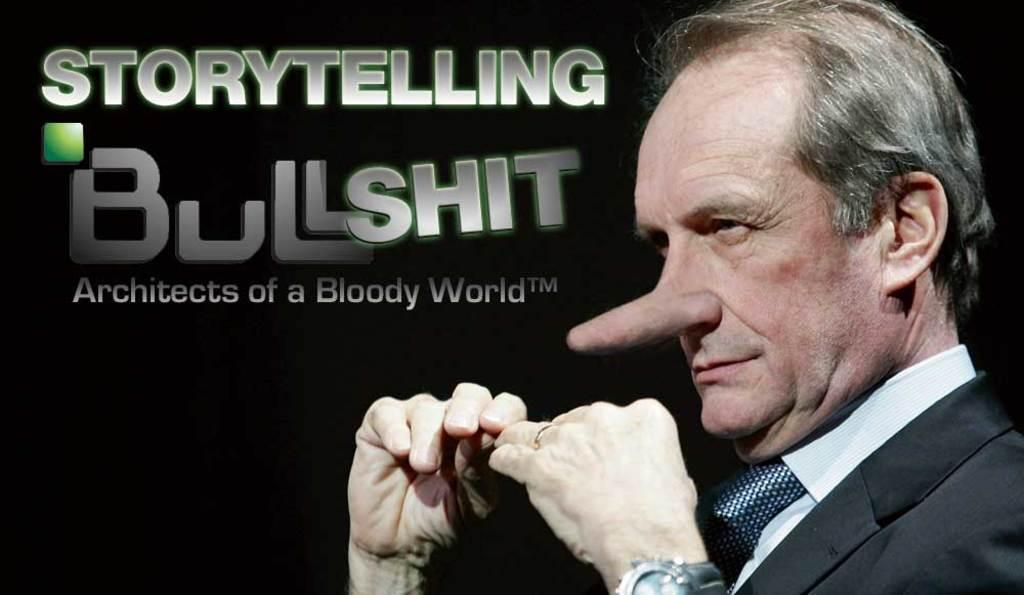What is located on the right side of the image? There is a man on the right side of the image. Can you describe the man's appearance? The man's nose appears to be larger than usual. Where can we find any text in the image? The texts are written on the image, located on the left at the top. What type of hat is the man wearing in the image? There is no hat visible in the image; the man's nose is the focus of the description. 